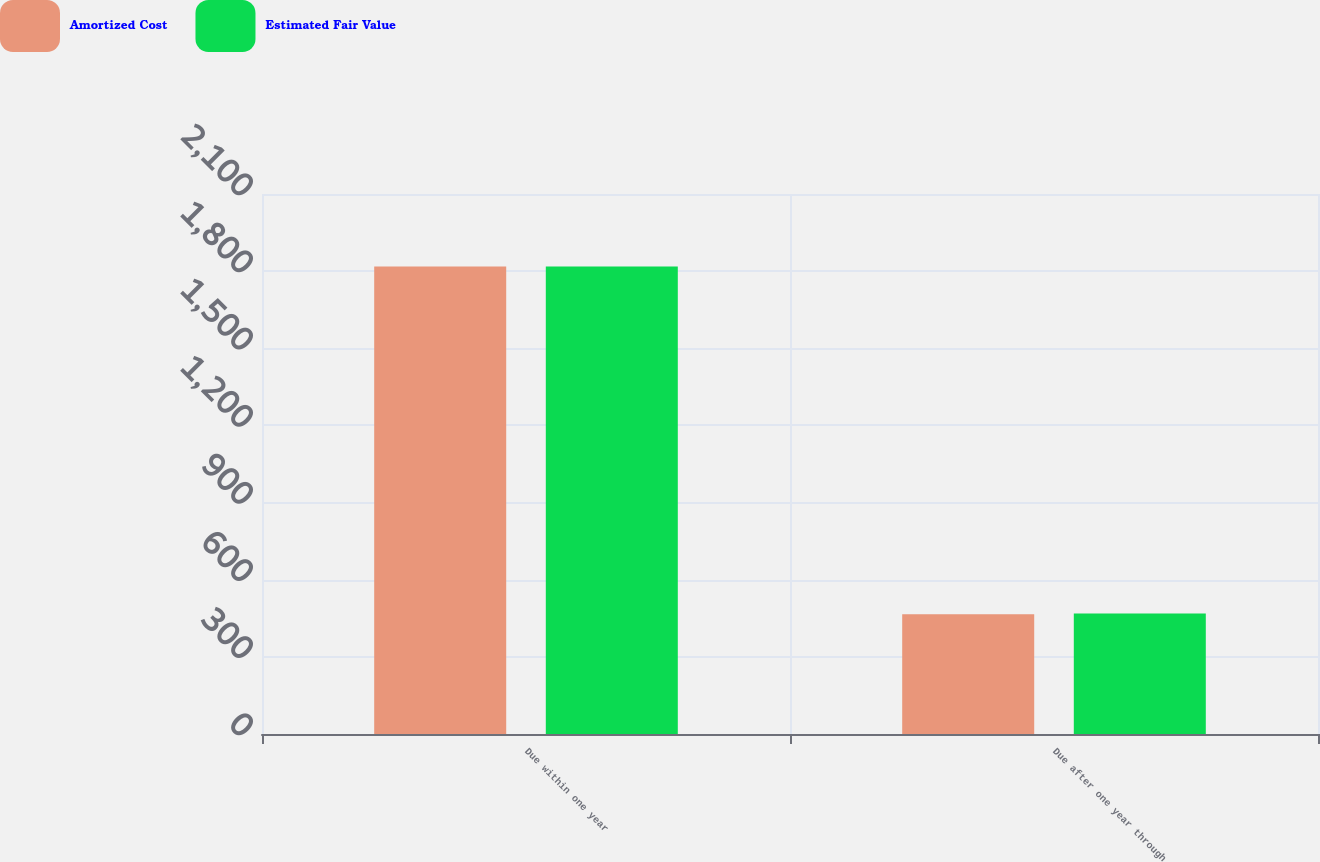<chart> <loc_0><loc_0><loc_500><loc_500><stacked_bar_chart><ecel><fcel>Due within one year<fcel>Due after one year through<nl><fcel>Amortized Cost<fcel>1818<fcel>466<nl><fcel>Estimated Fair Value<fcel>1818<fcel>469<nl></chart> 